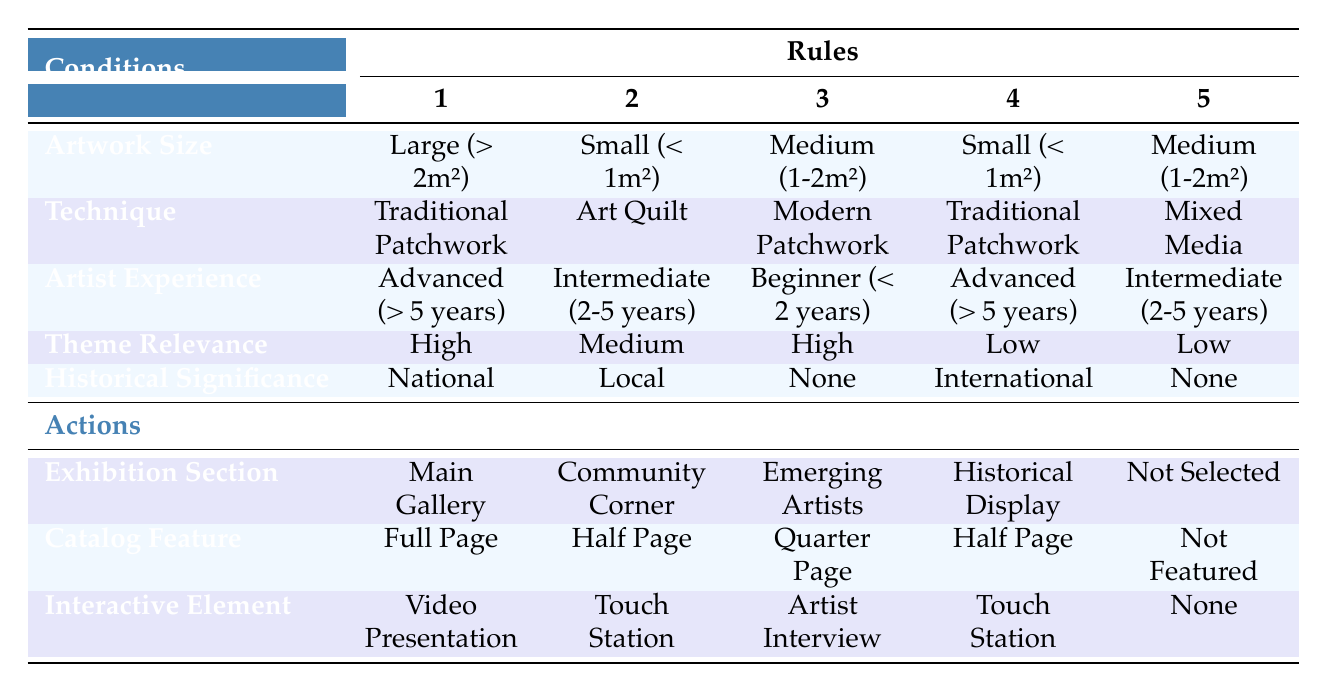What is the exhibition section for artworks that are Large, Traditional Patchwork, Advanced experience, High relevance, and National significance? According to the table, this specific condition matches Rule 1. The corresponding action for this rule under Exhibition Section is "Main Gallery."
Answer: Main Gallery Which catalog feature is assigned to artworks that are Small, Art Quilt, Intermediate experience, Medium relevance, and Local significance? By examining Rule 2 in the table, the action for this combination is "Half Page" under Catalog Feature.
Answer: Half Page Is there any artwork categorized for the "Not Selected" section? Yes, Rule 5 indicates that a combination of Medium size, Mixed Media technique, Intermediate experience, Low relevance, and None historical significance leads to the Not Selected action.
Answer: Yes What is the interactive element for artworks that are Medium, Modern Patchwork, Beginner experience, High relevance, and None significance? Looking at Rule 3, we can see that these conditions correspond to the action "Artist Interview" under Interactive Element.
Answer: Artist Interview How many artworks have a High theme relevance, and what are their exhibition sections? There are two applicable rules: Rule 1 with "Main Gallery" and Rule 3 with "Emerging Artists." Summarizing these conditions, the High theme relevance leads to two different exhibition sections.
Answer: Two (Main Gallery, Emerging Artists) 